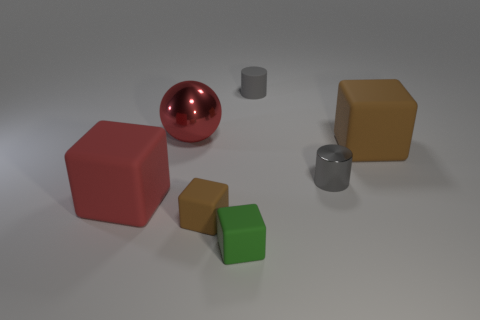Is the number of cubes behind the matte cylinder less than the number of brown matte things?
Your response must be concise. Yes. Are there any small purple rubber cubes?
Your response must be concise. No. The other small thing that is the same shape as the small brown thing is what color?
Offer a terse response. Green. Does the big matte object that is on the right side of the red matte block have the same color as the small metallic thing?
Give a very brief answer. No. Do the green object and the red rubber thing have the same size?
Provide a succinct answer. No. There is a gray object that is made of the same material as the green object; what is its shape?
Keep it short and to the point. Cylinder. What number of other objects are there of the same shape as the big brown rubber thing?
Your response must be concise. 3. The brown thing in front of the rubber block to the left of the brown object on the left side of the gray shiny object is what shape?
Keep it short and to the point. Cube. What number of balls are red rubber objects or small gray things?
Keep it short and to the point. 0. Is there a red ball that is behind the brown thing to the left of the tiny green block?
Your response must be concise. Yes. 